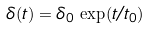Convert formula to latex. <formula><loc_0><loc_0><loc_500><loc_500>\delta ( t ) = \delta _ { 0 } \, \exp ( t / t _ { 0 } )</formula> 